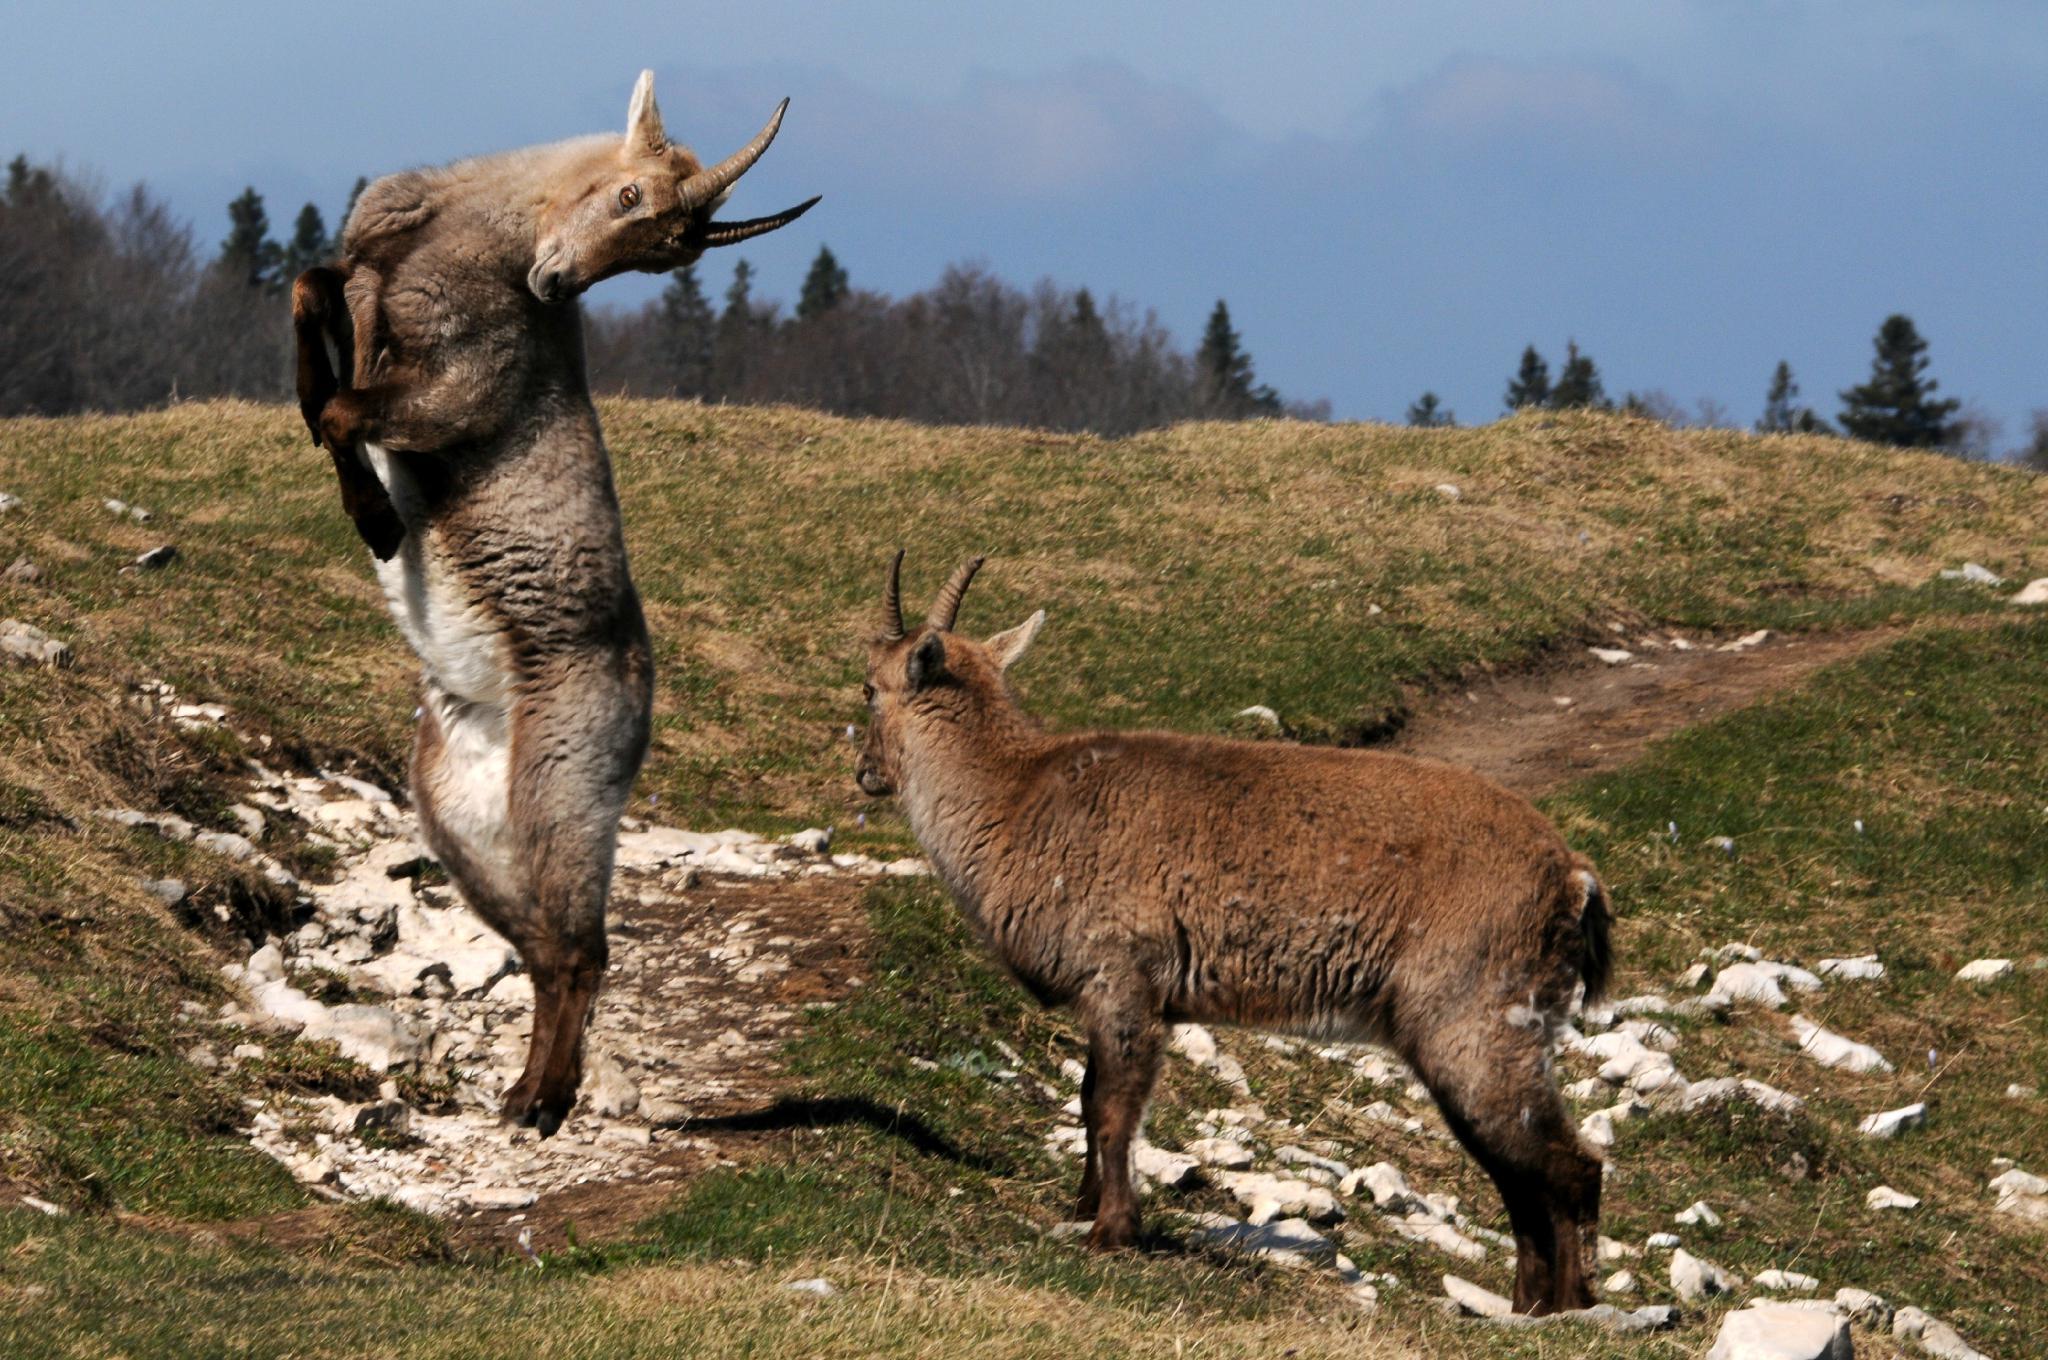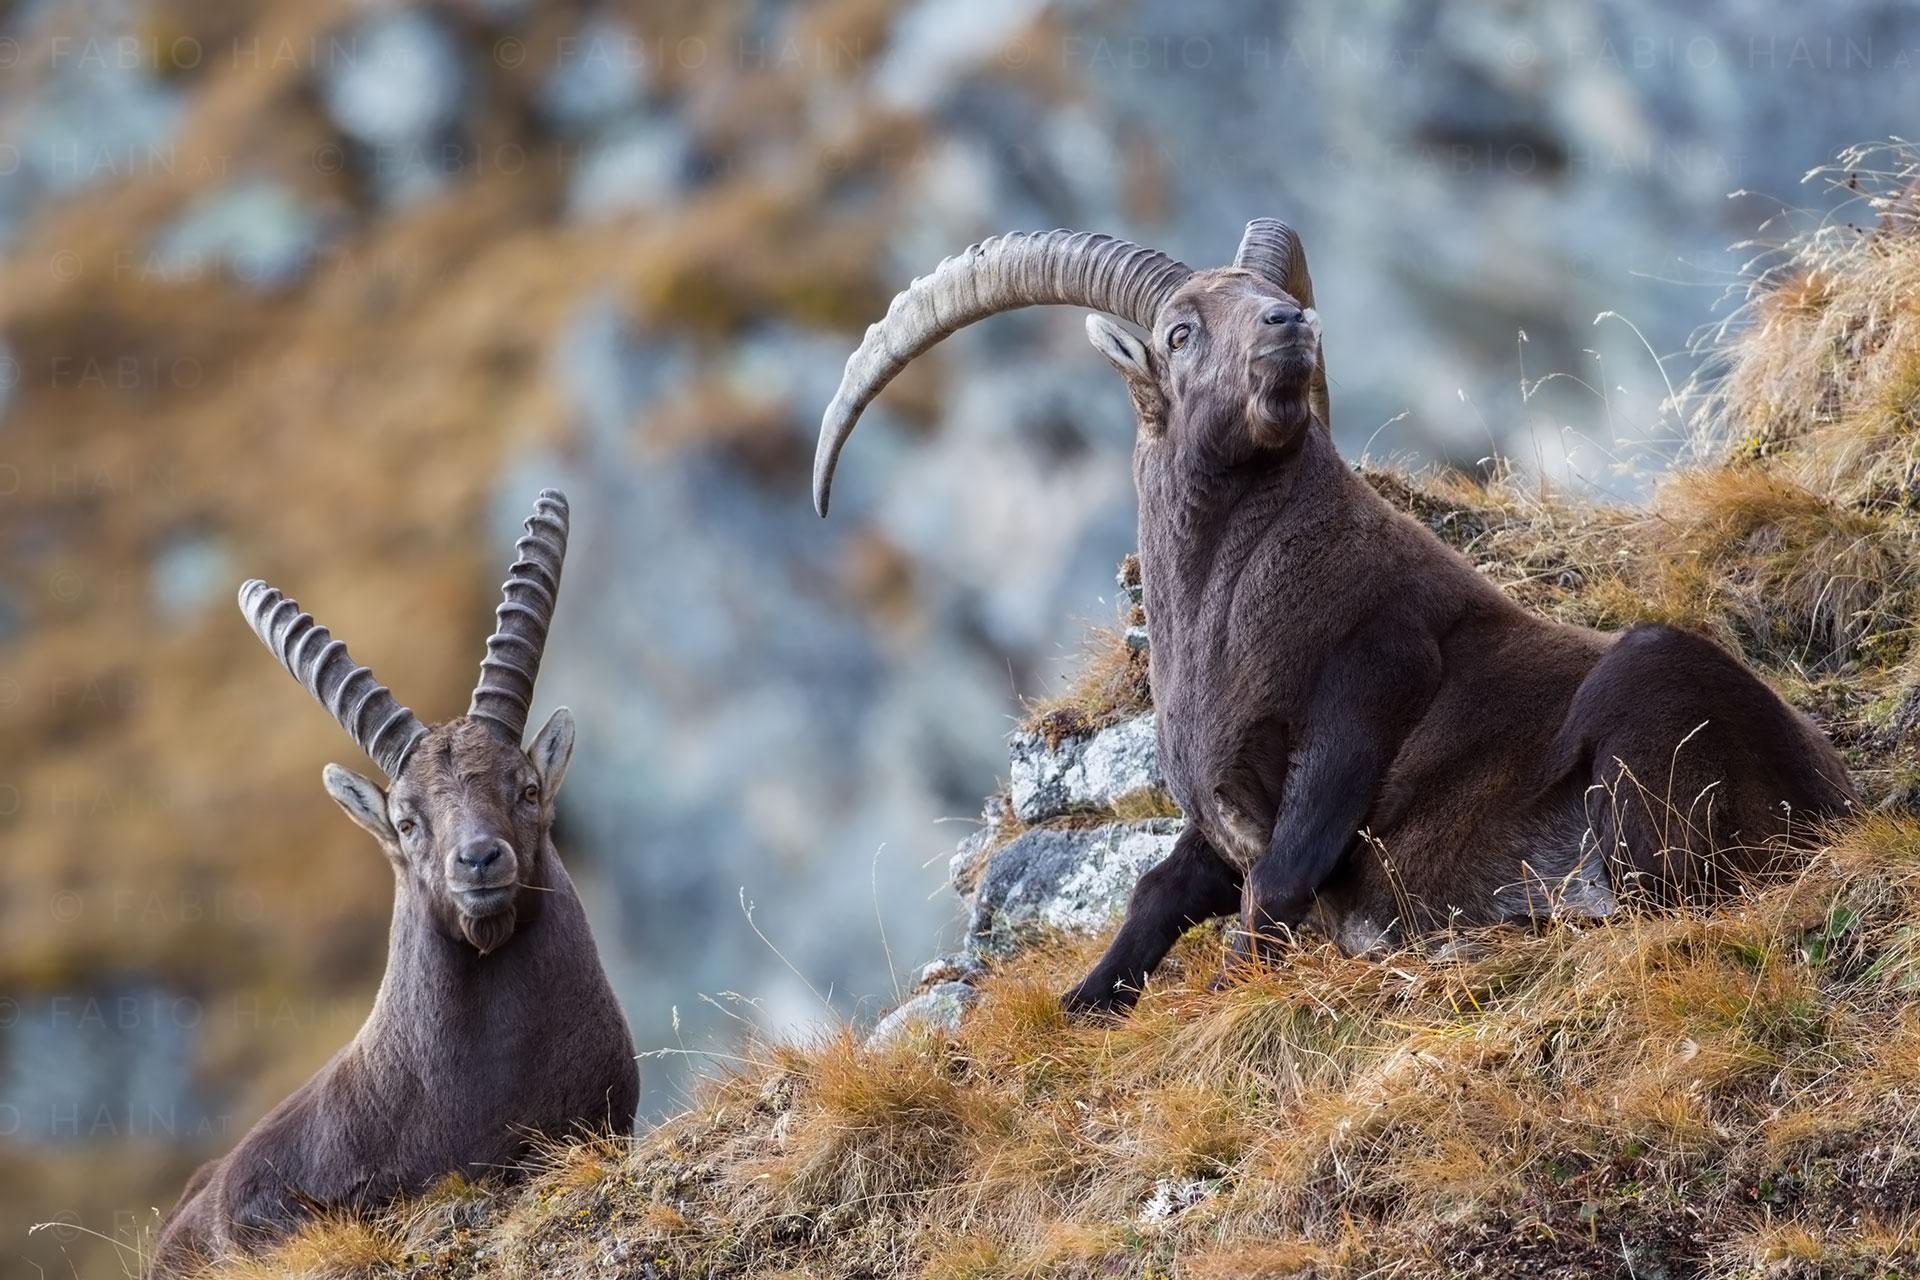The first image is the image on the left, the second image is the image on the right. For the images displayed, is the sentence "In one image, an antelope is resting with its body on the ground." factually correct? Answer yes or no. Yes. 